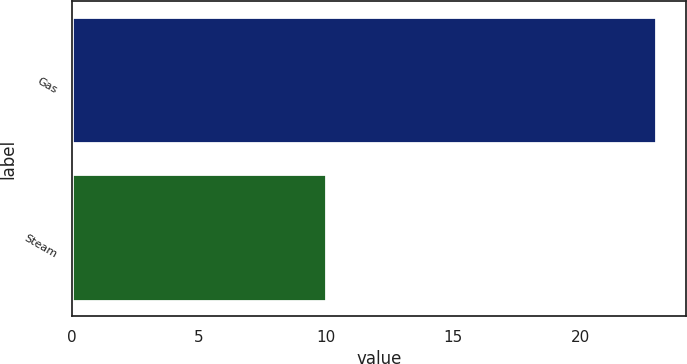<chart> <loc_0><loc_0><loc_500><loc_500><bar_chart><fcel>Gas<fcel>Steam<nl><fcel>23<fcel>10<nl></chart> 